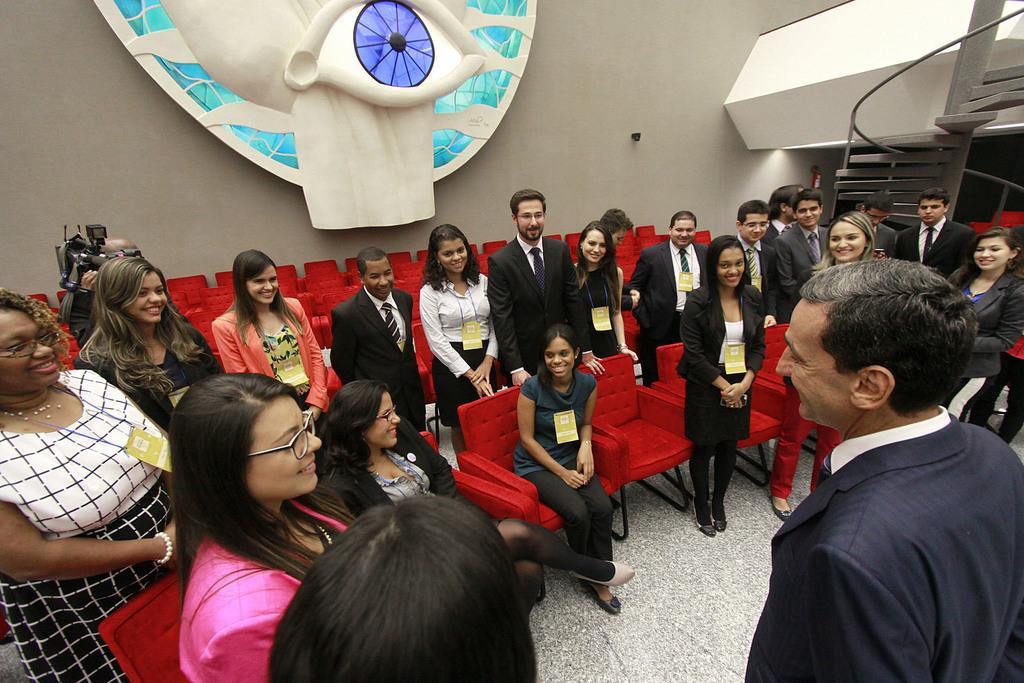In one or two sentences, can you explain what this image depicts? In front of the image there are a few people standing on the floor and there are a few people sitting on the chairs. There is a person holding the camera. In the background of the image there are stairs, railing. There is some object on the wall. 